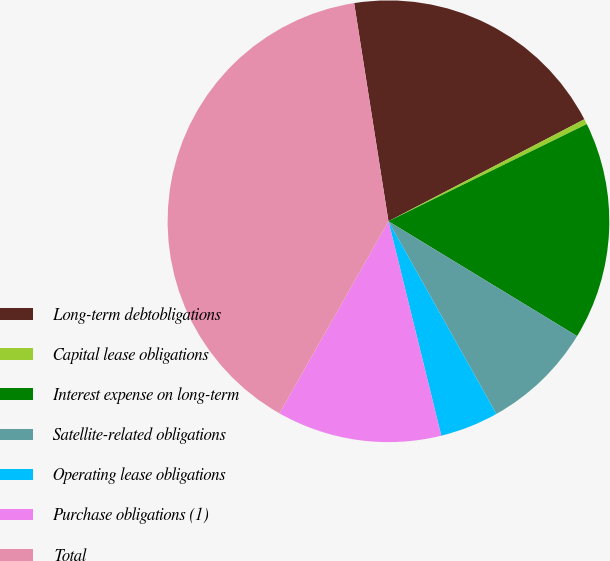Convert chart to OTSL. <chart><loc_0><loc_0><loc_500><loc_500><pie_chart><fcel>Long-term debtobligations<fcel>Capital lease obligations<fcel>Interest expense on long-term<fcel>Satellite-related obligations<fcel>Operating lease obligations<fcel>Purchase obligations (1)<fcel>Total<nl><fcel>19.84%<fcel>0.39%<fcel>15.95%<fcel>8.17%<fcel>4.28%<fcel>12.06%<fcel>39.29%<nl></chart> 